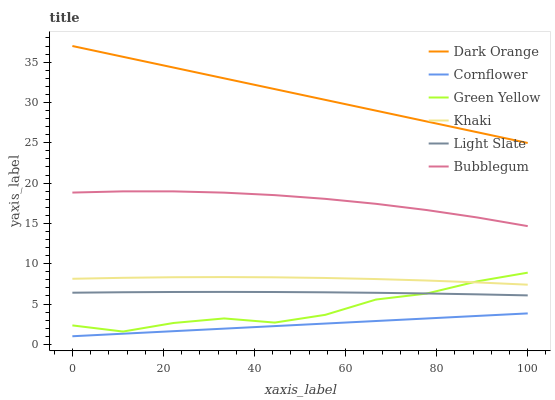Does Cornflower have the minimum area under the curve?
Answer yes or no. Yes. Does Dark Orange have the maximum area under the curve?
Answer yes or no. Yes. Does Khaki have the minimum area under the curve?
Answer yes or no. No. Does Khaki have the maximum area under the curve?
Answer yes or no. No. Is Cornflower the smoothest?
Answer yes or no. Yes. Is Green Yellow the roughest?
Answer yes or no. Yes. Is Khaki the smoothest?
Answer yes or no. No. Is Khaki the roughest?
Answer yes or no. No. Does Cornflower have the lowest value?
Answer yes or no. Yes. Does Khaki have the lowest value?
Answer yes or no. No. Does Dark Orange have the highest value?
Answer yes or no. Yes. Does Khaki have the highest value?
Answer yes or no. No. Is Khaki less than Dark Orange?
Answer yes or no. Yes. Is Bubblegum greater than Green Yellow?
Answer yes or no. Yes. Does Green Yellow intersect Khaki?
Answer yes or no. Yes. Is Green Yellow less than Khaki?
Answer yes or no. No. Is Green Yellow greater than Khaki?
Answer yes or no. No. Does Khaki intersect Dark Orange?
Answer yes or no. No. 